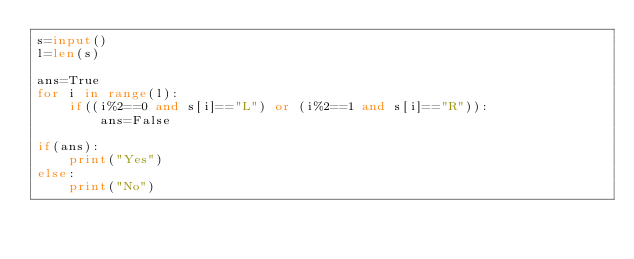<code> <loc_0><loc_0><loc_500><loc_500><_Python_>s=input()
l=len(s)

ans=True
for i in range(l):
    if((i%2==0 and s[i]=="L") or (i%2==1 and s[i]=="R")):
        ans=False

if(ans):
    print("Yes")
else:
    print("No")</code> 